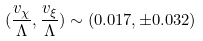Convert formula to latex. <formula><loc_0><loc_0><loc_500><loc_500>( \frac { v _ { \chi } } { \Lambda } , \frac { v _ { \xi } } { \Lambda } ) \sim ( 0 . 0 1 7 , \pm 0 . 0 3 2 )</formula> 